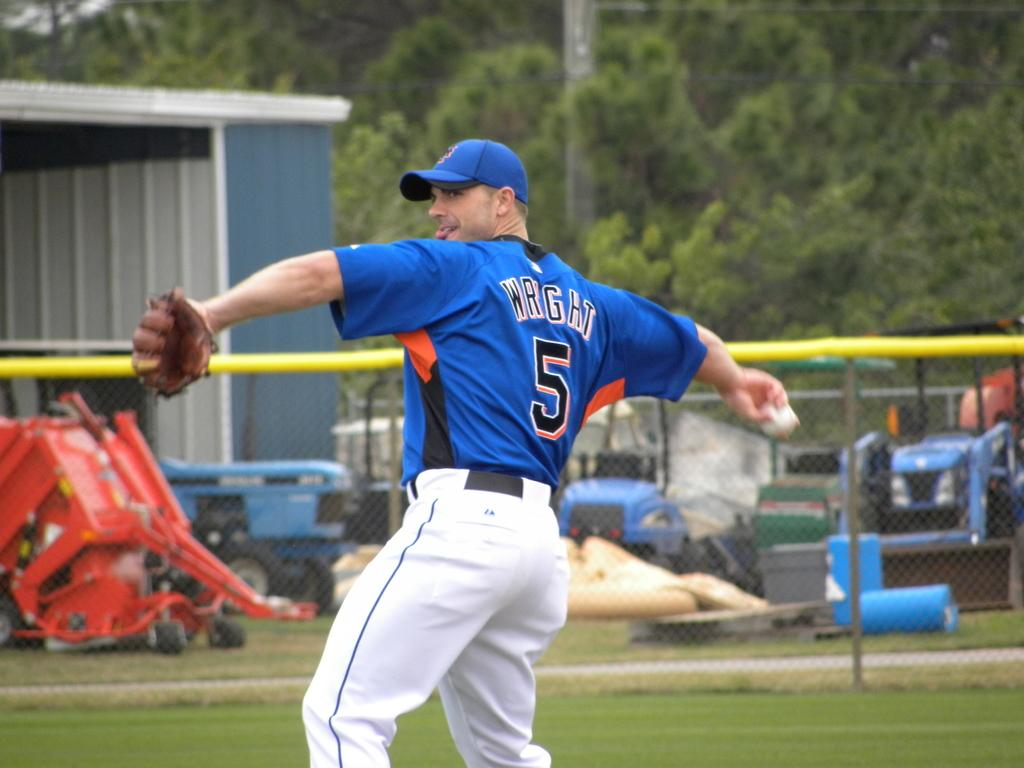<image>
Share a concise interpretation of the image provided. number 5 wright getting ready to throw baseball and farm equipment in the background 